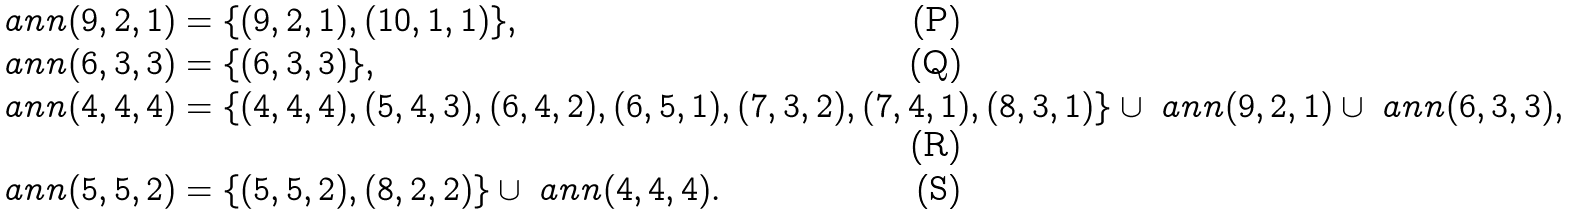Convert formula to latex. <formula><loc_0><loc_0><loc_500><loc_500>\ a n n ( 9 , 2 , 1 ) & = \{ ( 9 , 2 , 1 ) , ( 1 0 , 1 , 1 ) \} , \\ \ a n n ( 6 , 3 , 3 ) & = \{ ( 6 , 3 , 3 ) \} , \\ \ a n n ( 4 , 4 , 4 ) & = \{ ( 4 , 4 , 4 ) , ( 5 , 4 , 3 ) , ( 6 , 4 , 2 ) , ( 6 , 5 , 1 ) , ( 7 , 3 , 2 ) , ( 7 , 4 , 1 ) , ( 8 , 3 , 1 ) \} \cup \ a n n ( 9 , 2 , 1 ) \cup \ a n n ( 6 , 3 , 3 ) , \\ \ a n n ( 5 , 5 , 2 ) & = \{ ( 5 , 5 , 2 ) , ( 8 , 2 , 2 ) \} \cup \ a n n ( 4 , 4 , 4 ) .</formula> 